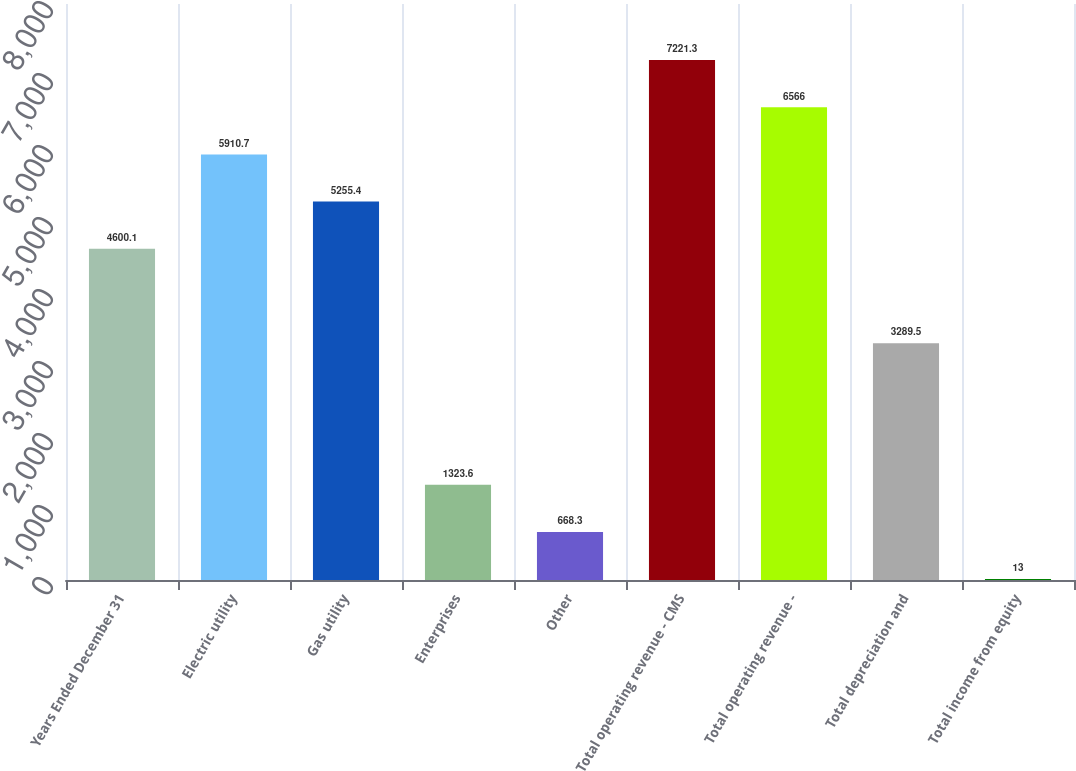Convert chart. <chart><loc_0><loc_0><loc_500><loc_500><bar_chart><fcel>Years Ended December 31<fcel>Electric utility<fcel>Gas utility<fcel>Enterprises<fcel>Other<fcel>Total operating revenue - CMS<fcel>Total operating revenue -<fcel>Total depreciation and<fcel>Total income from equity<nl><fcel>4600.1<fcel>5910.7<fcel>5255.4<fcel>1323.6<fcel>668.3<fcel>7221.3<fcel>6566<fcel>3289.5<fcel>13<nl></chart> 